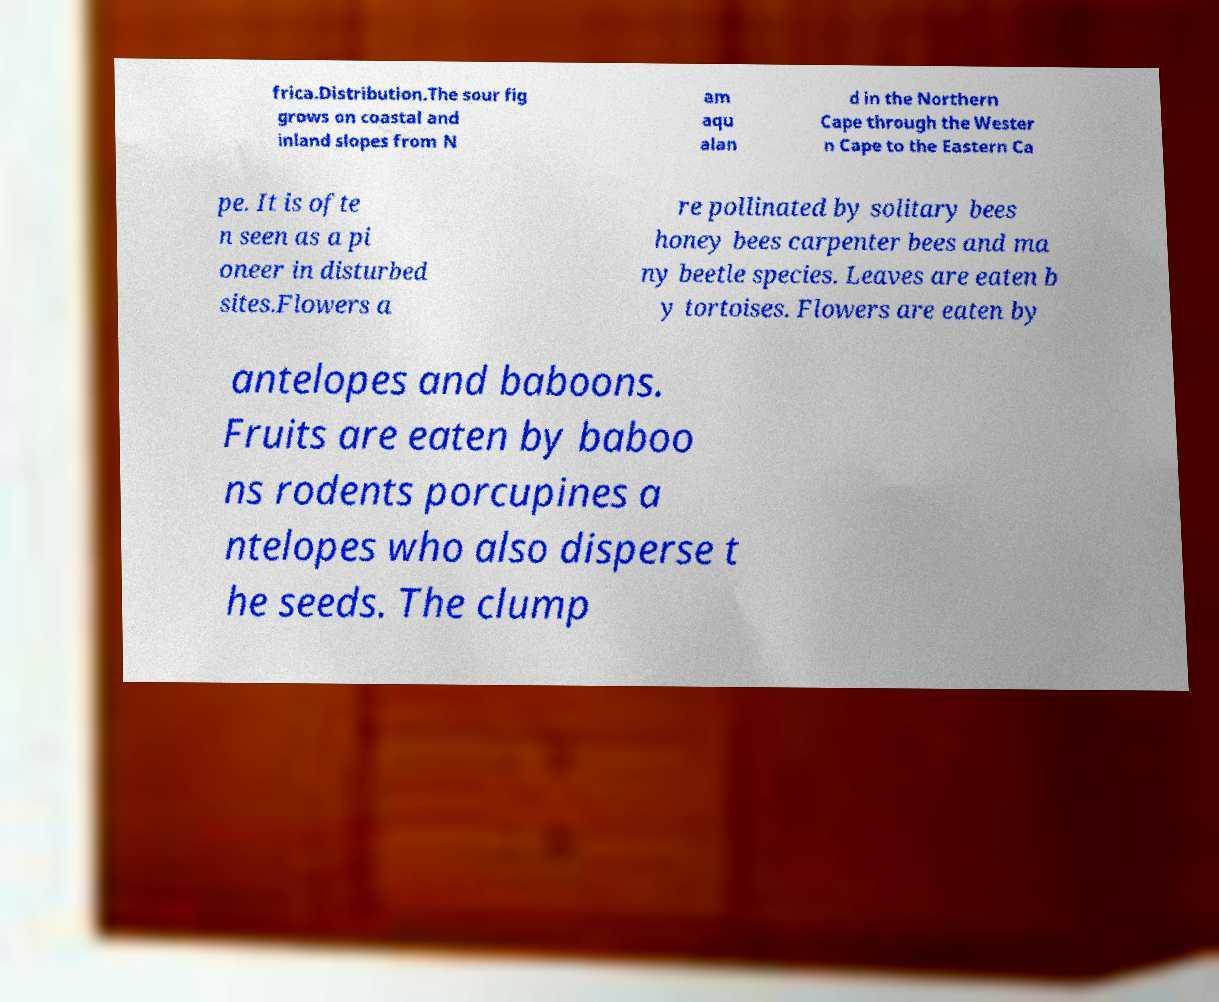Can you accurately transcribe the text from the provided image for me? frica.Distribution.The sour fig grows on coastal and inland slopes from N am aqu alan d in the Northern Cape through the Wester n Cape to the Eastern Ca pe. It is ofte n seen as a pi oneer in disturbed sites.Flowers a re pollinated by solitary bees honey bees carpenter bees and ma ny beetle species. Leaves are eaten b y tortoises. Flowers are eaten by antelopes and baboons. Fruits are eaten by baboo ns rodents porcupines a ntelopes who also disperse t he seeds. The clump 